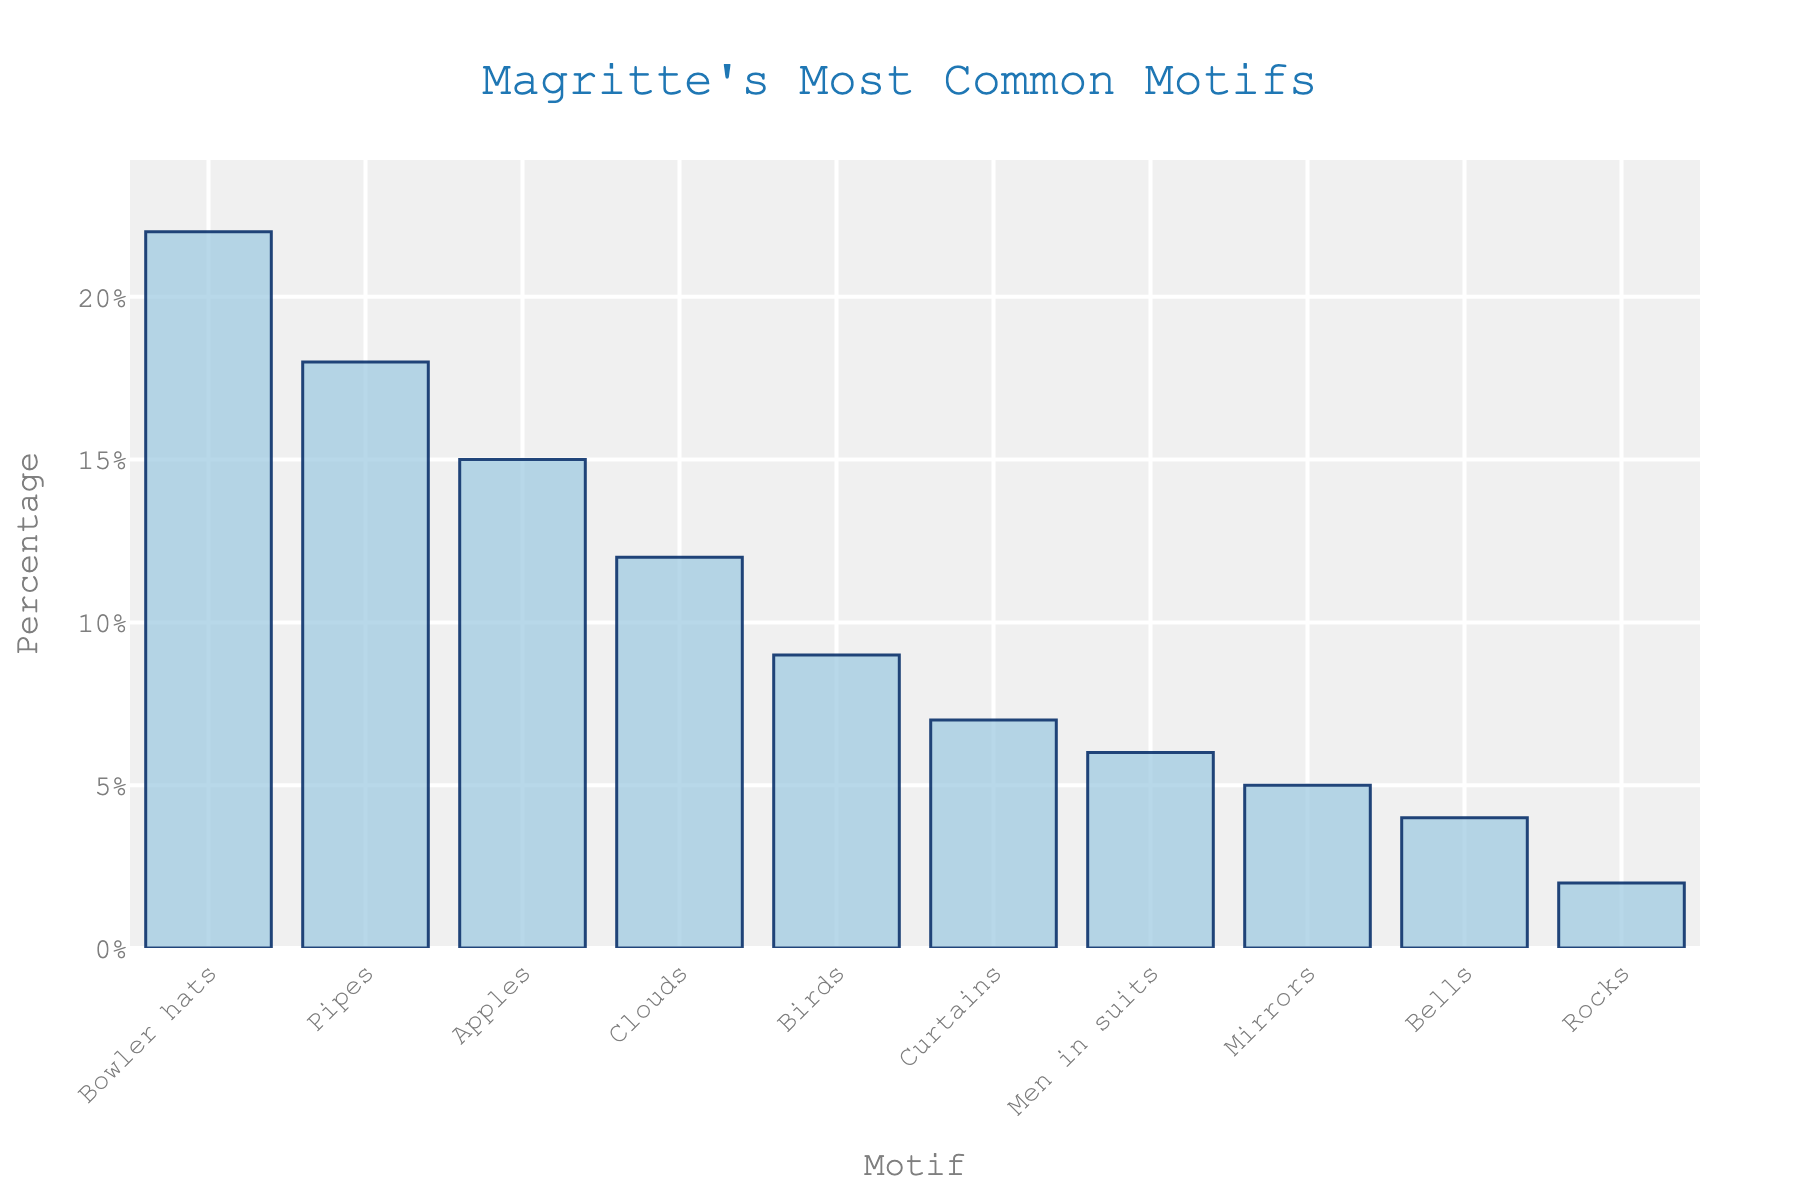Which motif is the most common in Magritte's works? The tallest bar represents the most common motif in Magritte's works, which is labeled as "Bowler hats" with a percentage of 22%.
Answer: Bowler hats How much more common are bowler hats compared to pipes? Bowler hats have a percentage of 22%, while pipes have a percentage of 18%. The difference is 22% - 18% = 4%.
Answer: 4% What is the combined percentage of apples and birds motifs in Magritte's works? The percentage for apples is 15% and for birds, it's 9%. The combined percentage is 15% + 9% = 24%.
Answer: 24% Which motifs have a representation of less than 10% in Magritte's works? The bar heights show motifs with percentages less than 10% are birds (9%), curtains (7%), men in suits (6%), mirrors (5%), bells (4%), and rocks (2%).
Answer: Birds, curtains, men in suits, mirrors, bells, rocks Is the percentage of clouds motifs greater than or equal to twice the percentage of mirrors motifs? The percentage of clouds motifs is 12%. The percentage of mirrors motifs is 5%. Twice the percentage of mirrors is 5% * 2 = 10%. Since 12% > 10%, clouds are more than twice the mirrors' percentage.
Answer: Yes Which motif is less common, rocks or curtains? The bar lengths show that rocks have a percentage of 2% and curtains have a percentage of 7%. Since 2% < 7%, rocks are less common than curtains.
Answer: Rocks What percentage of Magritte's works feature clouds or men in suits motifs? The percentage for clouds is 12% and for men in suits it is 6%. The combined percentage is 12% + 6% = 18%.
Answer: 18% What is the approximate difference between the percentages of the most common and least common motifs? The most common motif is bowler hats with 22%, and the least common is rocks with 2%. The approximate difference is 22% - 2% = 20%.
Answer: 20% If we combine motifs that are below 10% each, what is their total percentage representation? The motifs below 10% are birds (9%), curtains (7%), men in suits (6%), mirrors (5%), bells (4%), and rocks (2%). The combined total is 9% + 7% + 6% + 5% + 4% + 2% = 33%.
Answer: 33% 